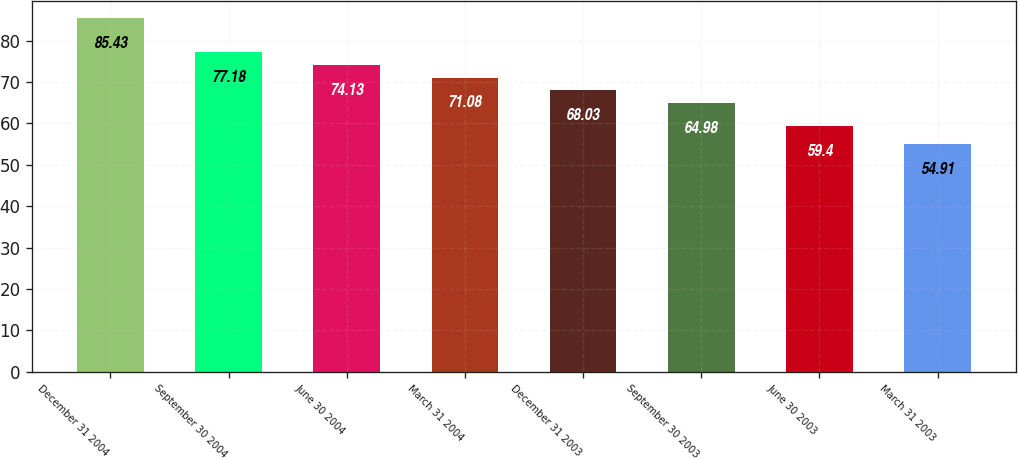<chart> <loc_0><loc_0><loc_500><loc_500><bar_chart><fcel>December 31 2004<fcel>September 30 2004<fcel>June 30 2004<fcel>March 31 2004<fcel>December 31 2003<fcel>September 30 2003<fcel>June 30 2003<fcel>March 31 2003<nl><fcel>85.43<fcel>77.18<fcel>74.13<fcel>71.08<fcel>68.03<fcel>64.98<fcel>59.4<fcel>54.91<nl></chart> 